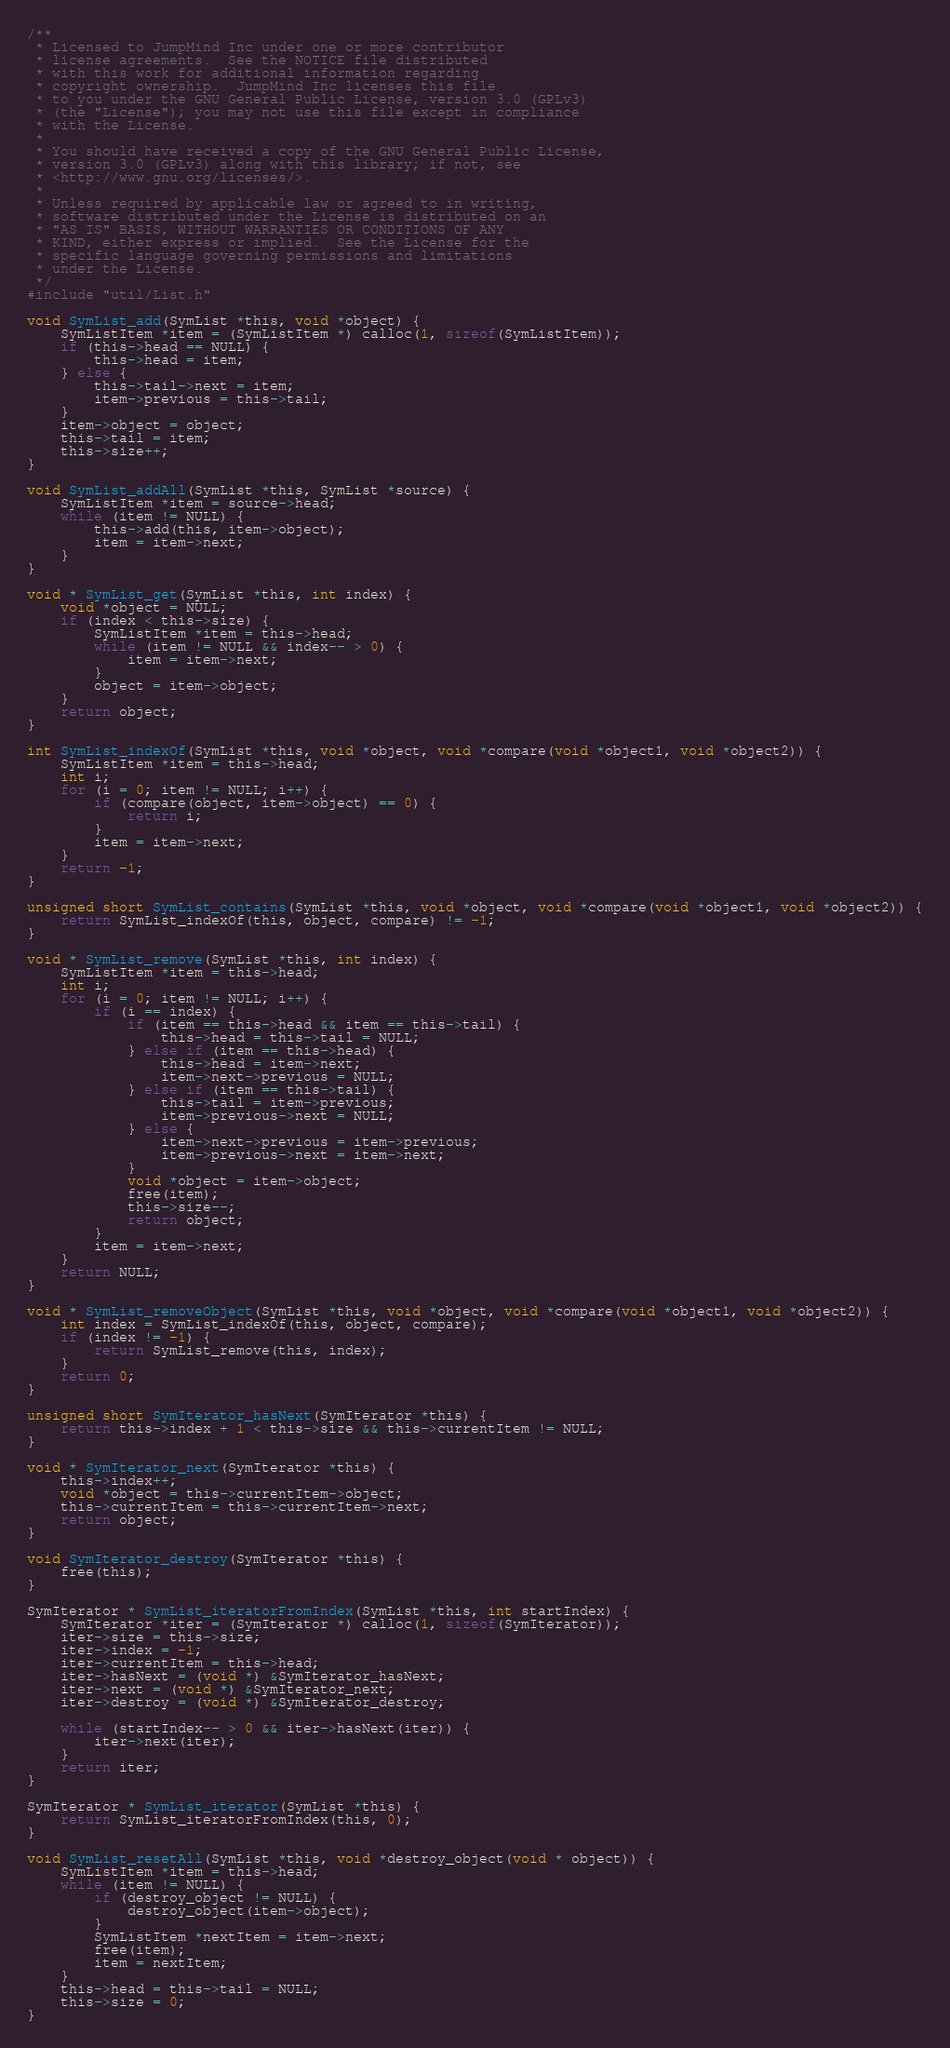Convert code to text. <code><loc_0><loc_0><loc_500><loc_500><_C_>/**
 * Licensed to JumpMind Inc under one or more contributor
 * license agreements.  See the NOTICE file distributed
 * with this work for additional information regarding
 * copyright ownership.  JumpMind Inc licenses this file
 * to you under the GNU General Public License, version 3.0 (GPLv3)
 * (the "License"); you may not use this file except in compliance
 * with the License.
 *
 * You should have received a copy of the GNU General Public License,
 * version 3.0 (GPLv3) along with this library; if not, see
 * <http://www.gnu.org/licenses/>.
 *
 * Unless required by applicable law or agreed to in writing,
 * software distributed under the License is distributed on an
 * "AS IS" BASIS, WITHOUT WARRANTIES OR CONDITIONS OF ANY
 * KIND, either express or implied.  See the License for the
 * specific language governing permissions and limitations
 * under the License.
 */
#include "util/List.h"

void SymList_add(SymList *this, void *object) {
    SymListItem *item = (SymListItem *) calloc(1, sizeof(SymListItem));
    if (this->head == NULL) {
        this->head = item;
    } else {
        this->tail->next = item;
        item->previous = this->tail;
    }
    item->object = object;
    this->tail = item;
    this->size++;
}

void SymList_addAll(SymList *this, SymList *source) {
    SymListItem *item = source->head;
    while (item != NULL) {
        this->add(this, item->object);
        item = item->next;
    }
}

void * SymList_get(SymList *this, int index) {
    void *object = NULL;
    if (index < this->size) {
        SymListItem *item = this->head;
        while (item != NULL && index-- > 0) {
            item = item->next;
        }
        object = item->object;
    }
    return object;
}

int SymList_indexOf(SymList *this, void *object, void *compare(void *object1, void *object2)) {
    SymListItem *item = this->head;
    int i;
    for (i = 0; item != NULL; i++) {
        if (compare(object, item->object) == 0) {
            return i;
        }
        item = item->next;
    }
    return -1;
}

unsigned short SymList_contains(SymList *this, void *object, void *compare(void *object1, void *object2)) {
    return SymList_indexOf(this, object, compare) != -1;
}

void * SymList_remove(SymList *this, int index) {
    SymListItem *item = this->head;
    int i;
    for (i = 0; item != NULL; i++) {
        if (i == index) {
            if (item == this->head && item == this->tail) {
                this->head = this->tail = NULL;
            } else if (item == this->head) {
                this->head = item->next;
                item->next->previous = NULL;
            } else if (item == this->tail) {
                this->tail = item->previous;
                item->previous->next = NULL;
            } else {
                item->next->previous = item->previous;
                item->previous->next = item->next;
            }
            void *object = item->object;
            free(item);
            this->size--;
            return object;
        }
        item = item->next;
    }
    return NULL;
}

void * SymList_removeObject(SymList *this, void *object, void *compare(void *object1, void *object2)) {
    int index = SymList_indexOf(this, object, compare);
    if (index != -1) {
        return SymList_remove(this, index);
    }
    return 0;
}

unsigned short SymIterator_hasNext(SymIterator *this) {
    return this->index + 1 < this->size && this->currentItem != NULL;
}

void * SymIterator_next(SymIterator *this) {
    this->index++;
    void *object = this->currentItem->object;
    this->currentItem = this->currentItem->next;
    return object;
}

void SymIterator_destroy(SymIterator *this) {
    free(this);
}

SymIterator * SymList_iteratorFromIndex(SymList *this, int startIndex) {
    SymIterator *iter = (SymIterator *) calloc(1, sizeof(SymIterator));
    iter->size = this->size;
    iter->index = -1;
    iter->currentItem = this->head;
    iter->hasNext = (void *) &SymIterator_hasNext;
    iter->next = (void *) &SymIterator_next;
    iter->destroy = (void *) &SymIterator_destroy;

    while (startIndex-- > 0 && iter->hasNext(iter)) {
        iter->next(iter);
    }
    return iter;
}

SymIterator * SymList_iterator(SymList *this) {
    return SymList_iteratorFromIndex(this, 0);
}

void SymList_resetAll(SymList *this, void *destroy_object(void * object)) {
    SymListItem *item = this->head;
    while (item != NULL) {
        if (destroy_object != NULL) {
            destroy_object(item->object);
        }
        SymListItem *nextItem = item->next;
        free(item);
        item = nextItem;
    }
    this->head = this->tail = NULL;
    this->size = 0;
}
</code> 